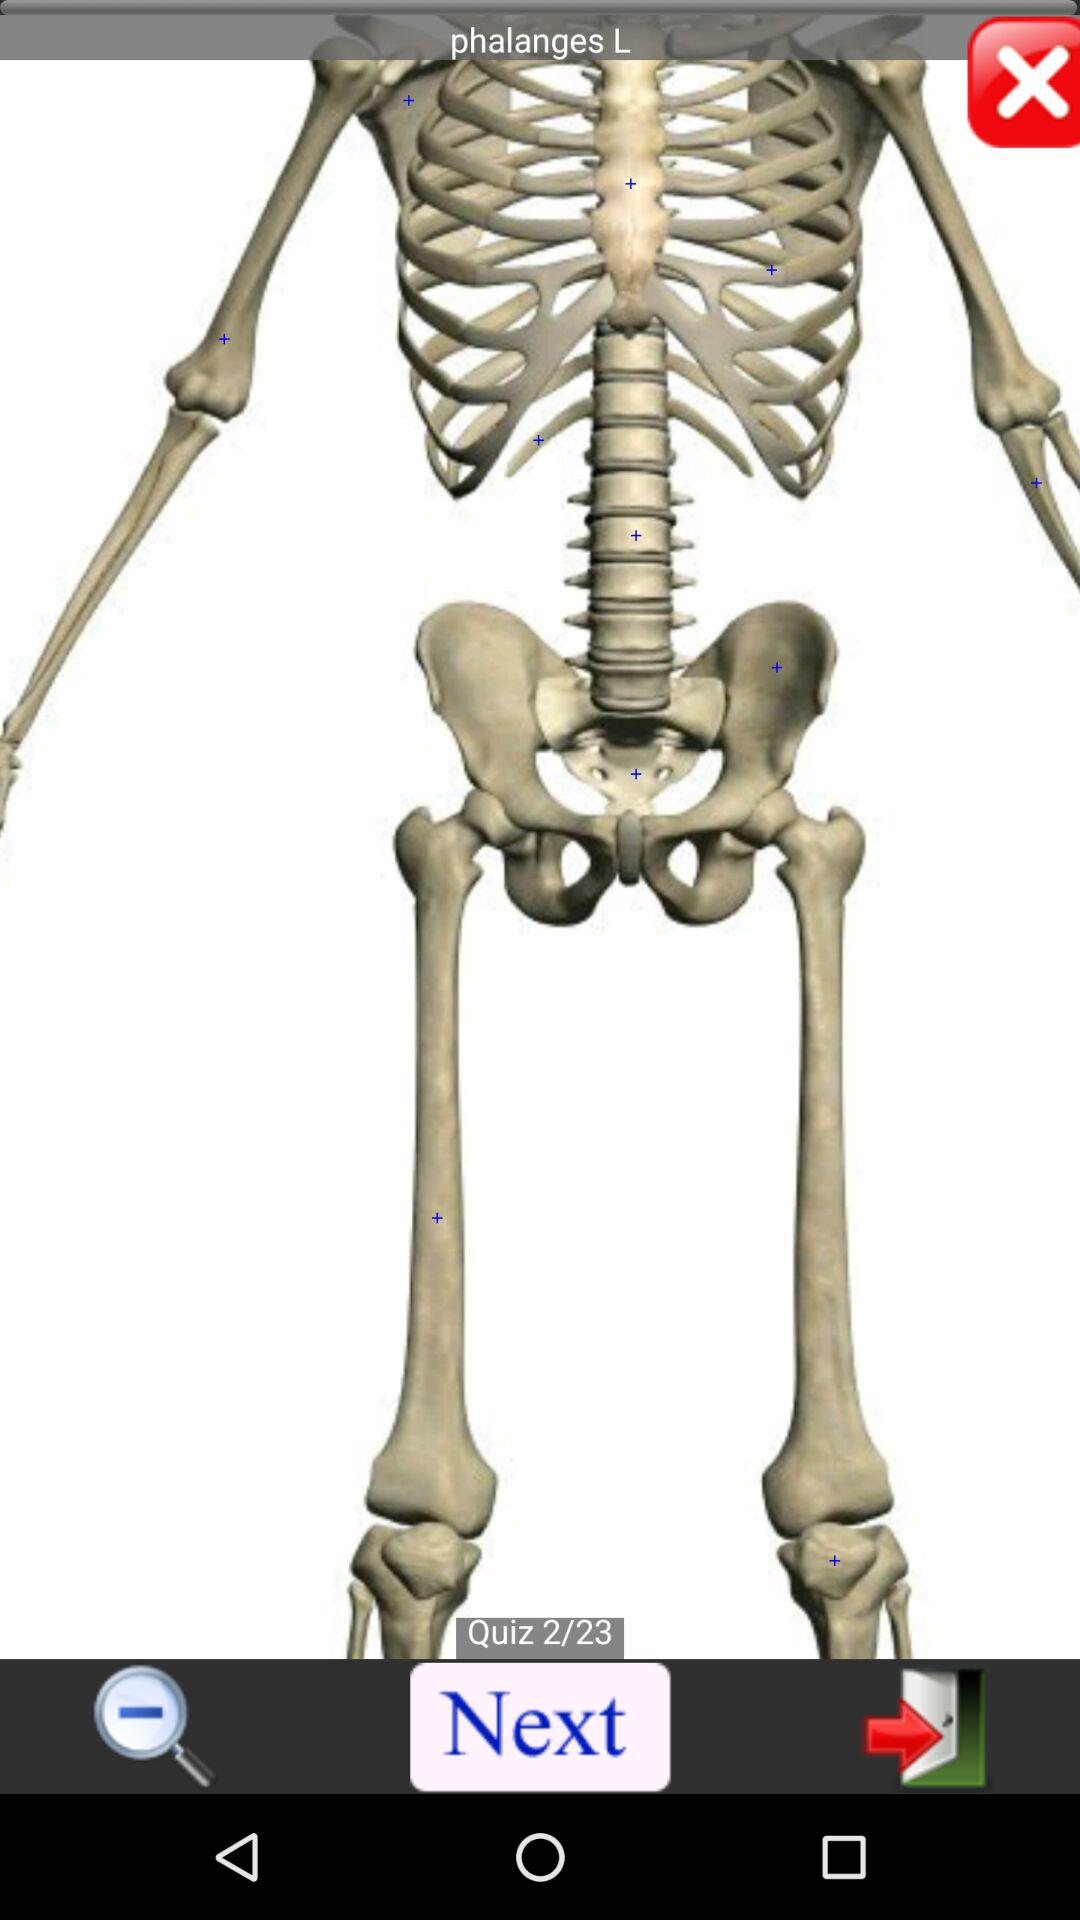How many quizzes in total are there? There are 23 quizzes in total. 